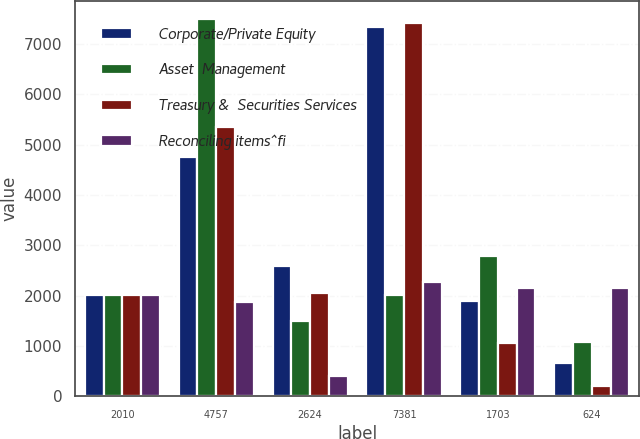Convert chart to OTSL. <chart><loc_0><loc_0><loc_500><loc_500><stacked_bar_chart><ecel><fcel>2010<fcel>4757<fcel>2624<fcel>7381<fcel>1703<fcel>624<nl><fcel>Corporate/Private Equity<fcel>2009<fcel>4747<fcel>2597<fcel>7344<fcel>1890<fcel>664<nl><fcel>Asset  Management<fcel>2010<fcel>7485<fcel>1499<fcel>2010<fcel>2786<fcel>1076<nl><fcel>Treasury &  Securities Services<fcel>2010<fcel>5359<fcel>2063<fcel>7422<fcel>1053<fcel>205<nl><fcel>Reconciling items^fi<fcel>2010<fcel>1866<fcel>403<fcel>2269<fcel>2148<fcel>2148<nl></chart> 